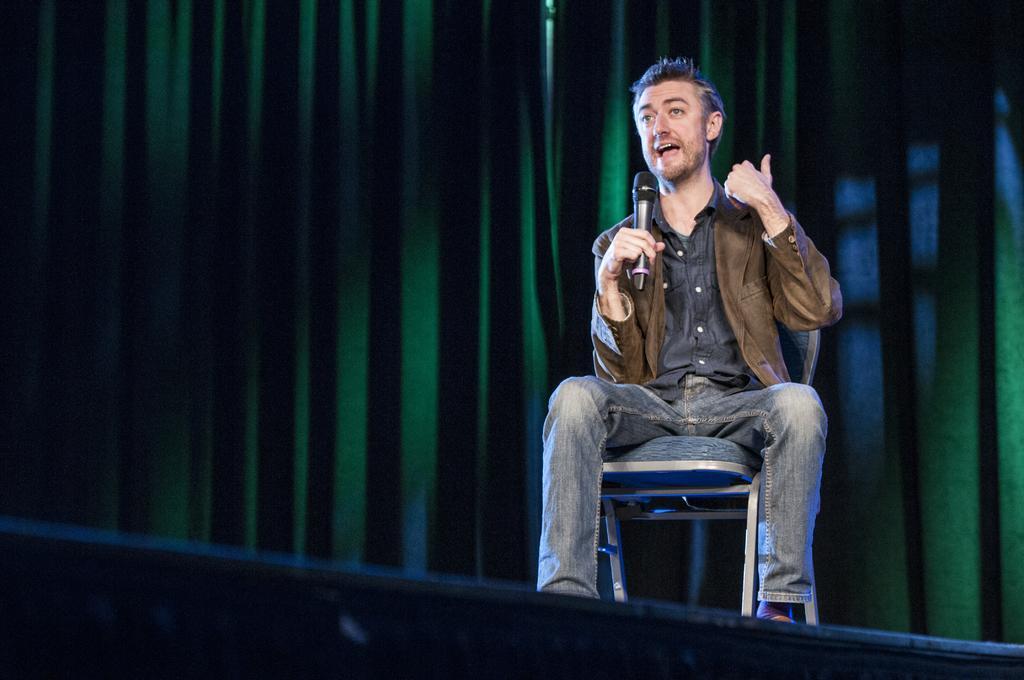Can you describe this image briefly? In this image there is one person who is sitting on chair he is holding a mike and talking, in the background there is a curtain. 